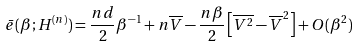<formula> <loc_0><loc_0><loc_500><loc_500>\bar { e } ( \beta ; H ^ { ( n ) } ) = \frac { n d } { 2 } \beta ^ { - 1 } + n \overline { V } - \frac { n \beta } { 2 } \left [ \overline { V ^ { 2 } } - \overline { V } ^ { 2 } \right ] + O ( \beta ^ { 2 } )</formula> 